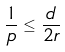<formula> <loc_0><loc_0><loc_500><loc_500>\frac { 1 } { p } \leq \frac { d } { 2 r }</formula> 